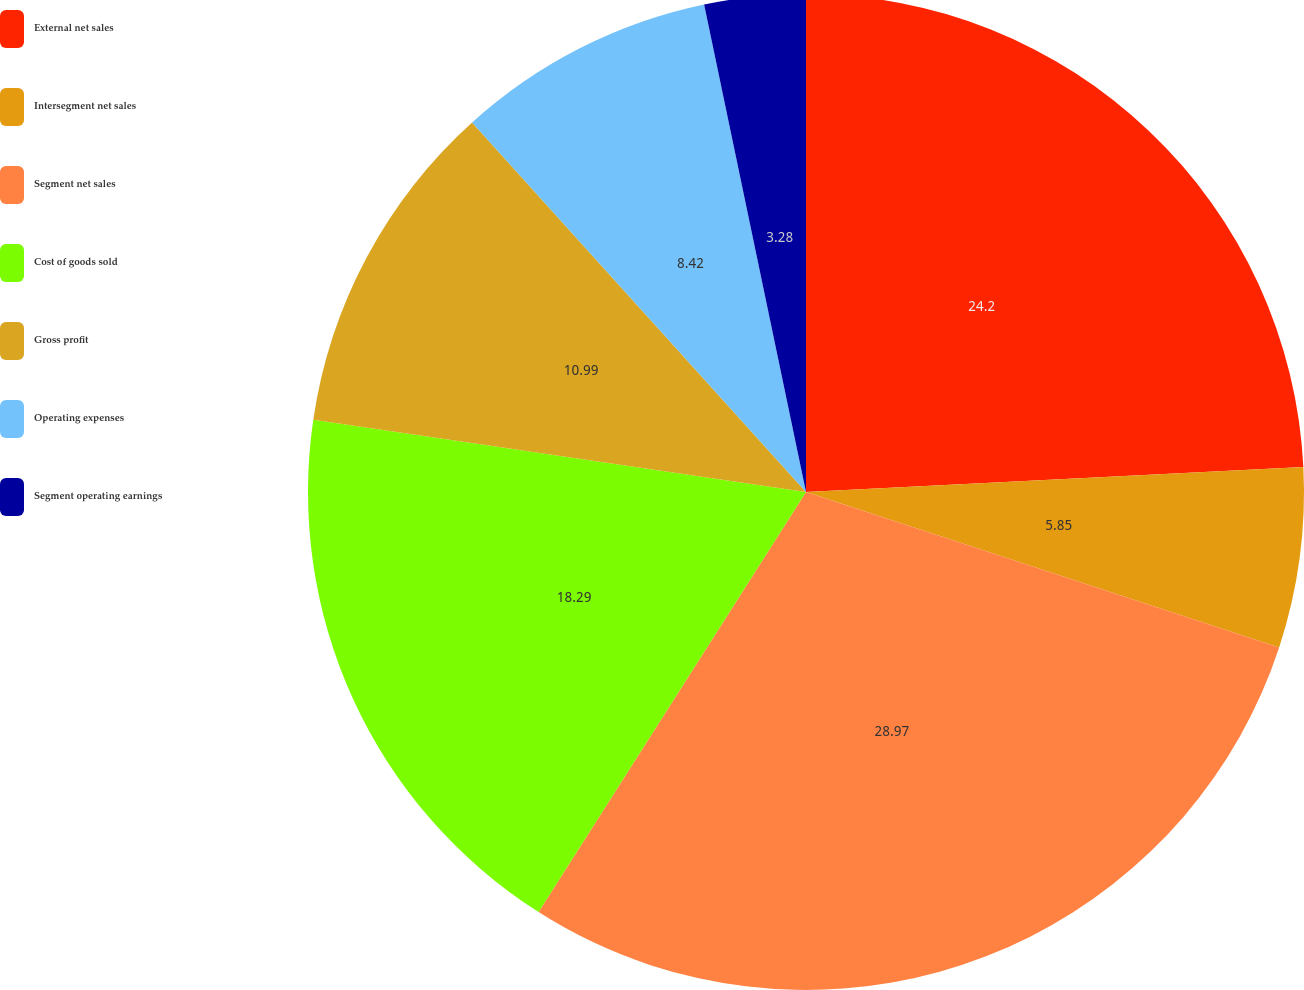Convert chart to OTSL. <chart><loc_0><loc_0><loc_500><loc_500><pie_chart><fcel>External net sales<fcel>Intersegment net sales<fcel>Segment net sales<fcel>Cost of goods sold<fcel>Gross profit<fcel>Operating expenses<fcel>Segment operating earnings<nl><fcel>24.21%<fcel>5.85%<fcel>28.98%<fcel>18.3%<fcel>10.99%<fcel>8.42%<fcel>3.28%<nl></chart> 